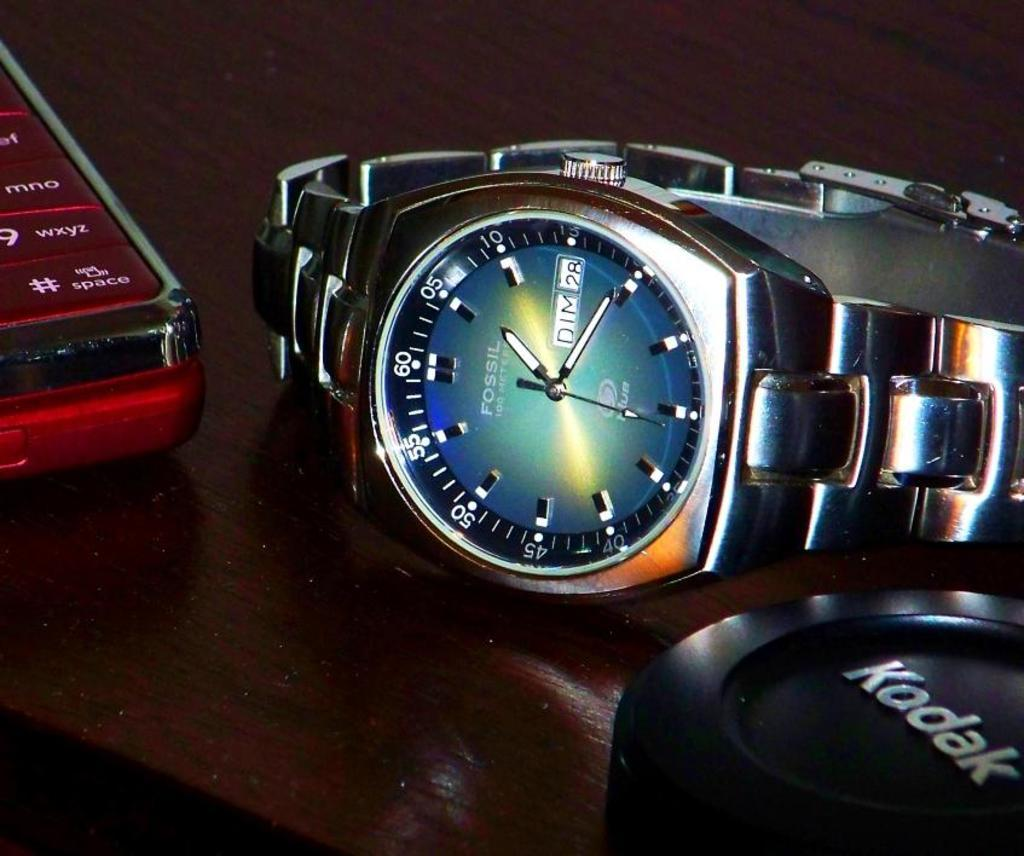What type of furniture is present in the image? There is a table in the image. What objects can be seen on the table? There is a fossil watch and a mobile phone on the table. Can you describe the color of one of the objects on the table? There is a black color object on the table. What type of hydrant is visible in the image? There is no hydrant present in the image. How does the mobile phone help the person believe in the fossil watch? The image does not show any connection between the mobile phone and the fossil watch, nor does it suggest that the mobile phone helps the person believe in the fossil watch. 